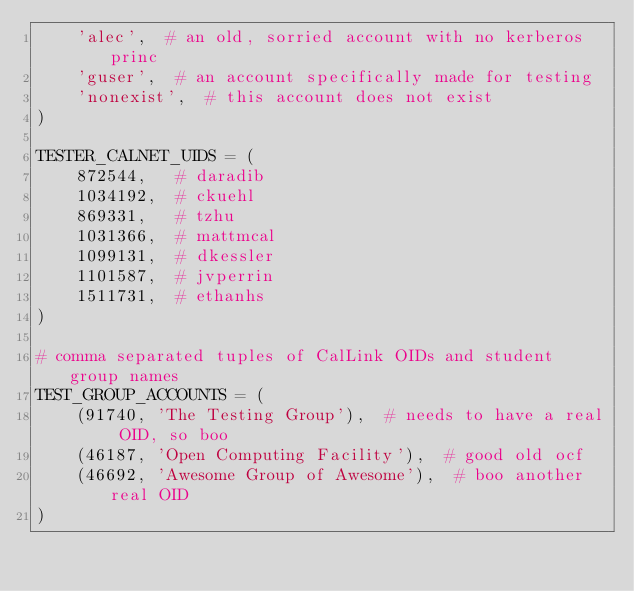Convert code to text. <code><loc_0><loc_0><loc_500><loc_500><_Python_>    'alec',  # an old, sorried account with no kerberos princ
    'guser',  # an account specifically made for testing
    'nonexist',  # this account does not exist
)

TESTER_CALNET_UIDS = (
    872544,   # daradib
    1034192,  # ckuehl
    869331,   # tzhu
    1031366,  # mattmcal
    1099131,  # dkessler
    1101587,  # jvperrin
    1511731,  # ethanhs
)

# comma separated tuples of CalLink OIDs and student group names
TEST_GROUP_ACCOUNTS = (
    (91740, 'The Testing Group'),  # needs to have a real OID, so boo
    (46187, 'Open Computing Facility'),  # good old ocf
    (46692, 'Awesome Group of Awesome'),  # boo another real OID
)
</code> 